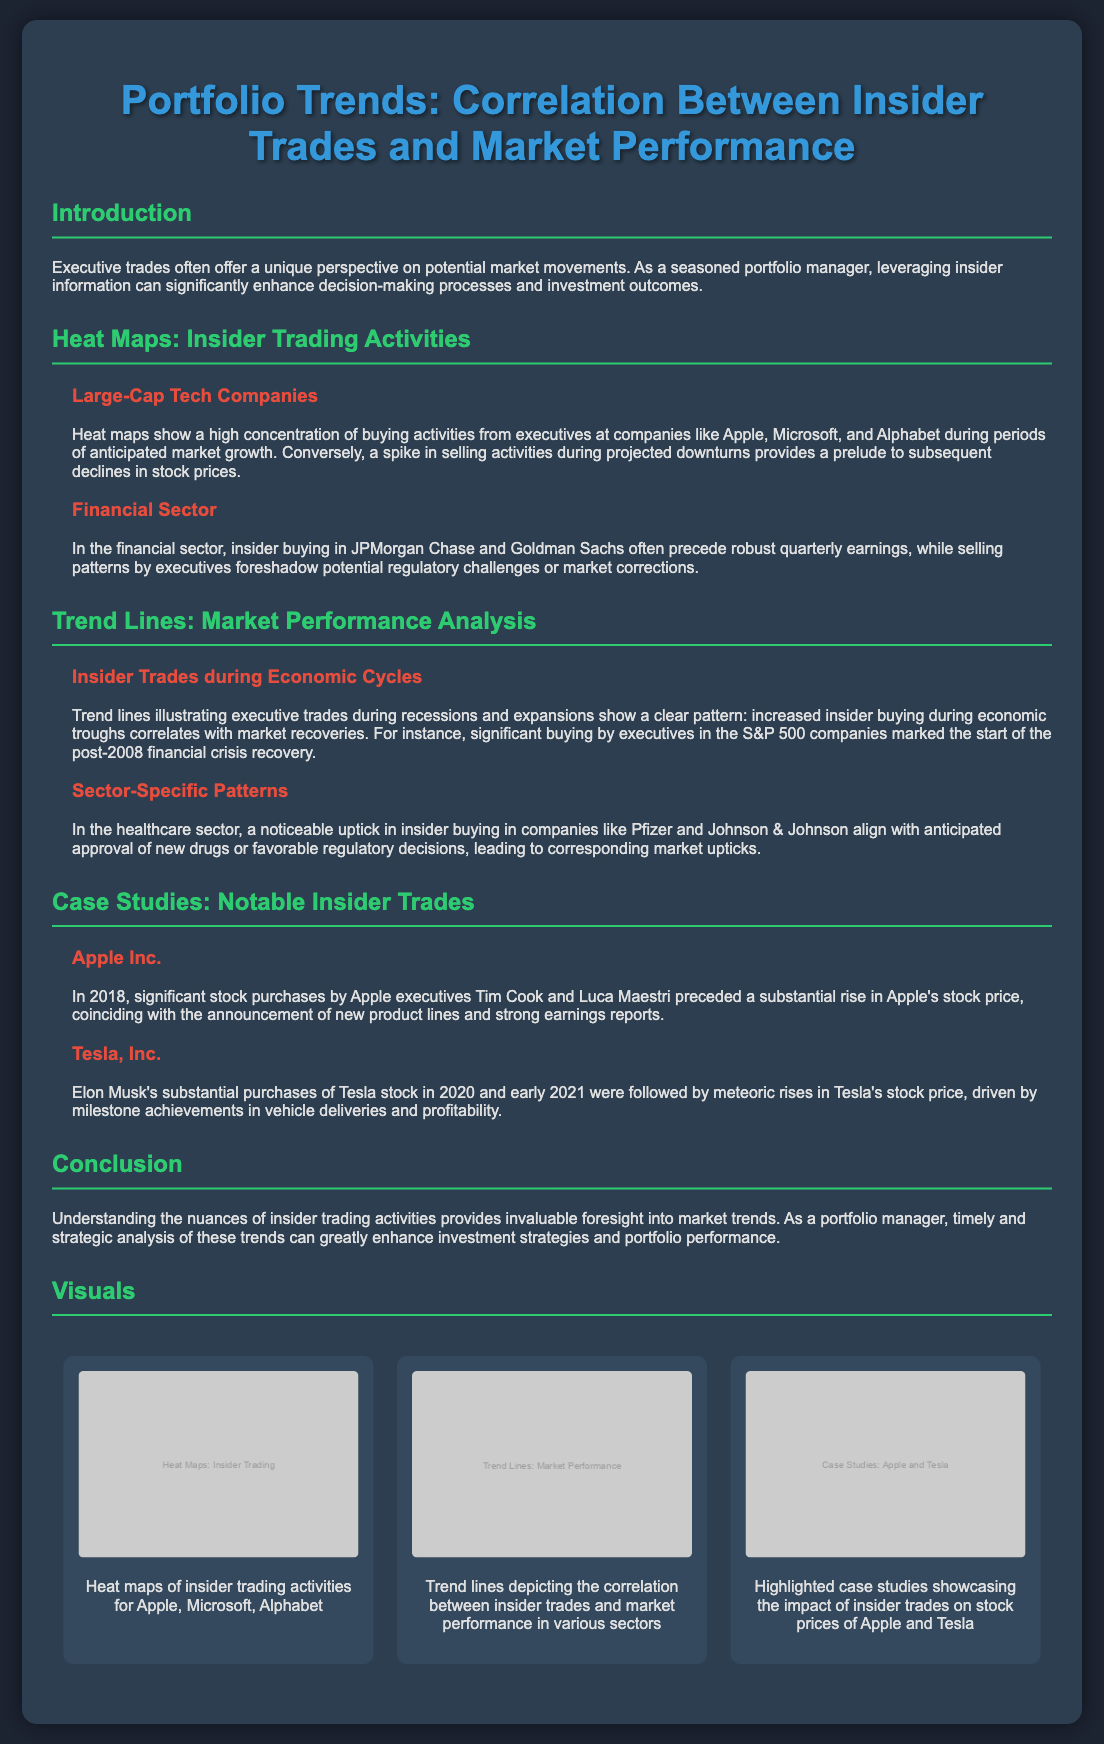what main theme is discussed in the poster? The main theme revolves around the correlation between insider trades and market performance.
Answer: correlation between insider trades and market performance which companies are highlighted in the heat maps for large-cap tech? The heat maps include buying activities from executives at companies specifically mentioned are Apple, Microsoft, and Alphabet.
Answer: Apple, Microsoft, and Alphabet what was a notable case study featured in the document? The notable case studies include significant trades related to Apple and Tesla which showcase their impact on stock prices.
Answer: Apple and Tesla which stock purchase preceded a rise in Apple's stock price in 2018? The significant purchases made by executives Tim Cook and Luca Maestri are highlighted in relation to Apple's stock price increase.
Answer: Tim Cook and Luca Maestri during which economic periods is there increased insider buying activity according to the trend lines? The trend lines indicate increased insider buying during economic troughs, correlating with market recoveries.
Answer: economic troughs what highlighted trend does insider buying in the financial sector correlate with? Insider buying in the financial sector specifically correlates with robust quarterly earnings, particularly in JPMorgan Chase and Goldman Sachs.
Answer: robust quarterly earnings which sector is mentioned to align insider buying with anticipated approval of new drugs? The healthcare sector shows a noticeable uptick in insider buying that aligns with anticipated approval of new drugs.
Answer: healthcare sector 